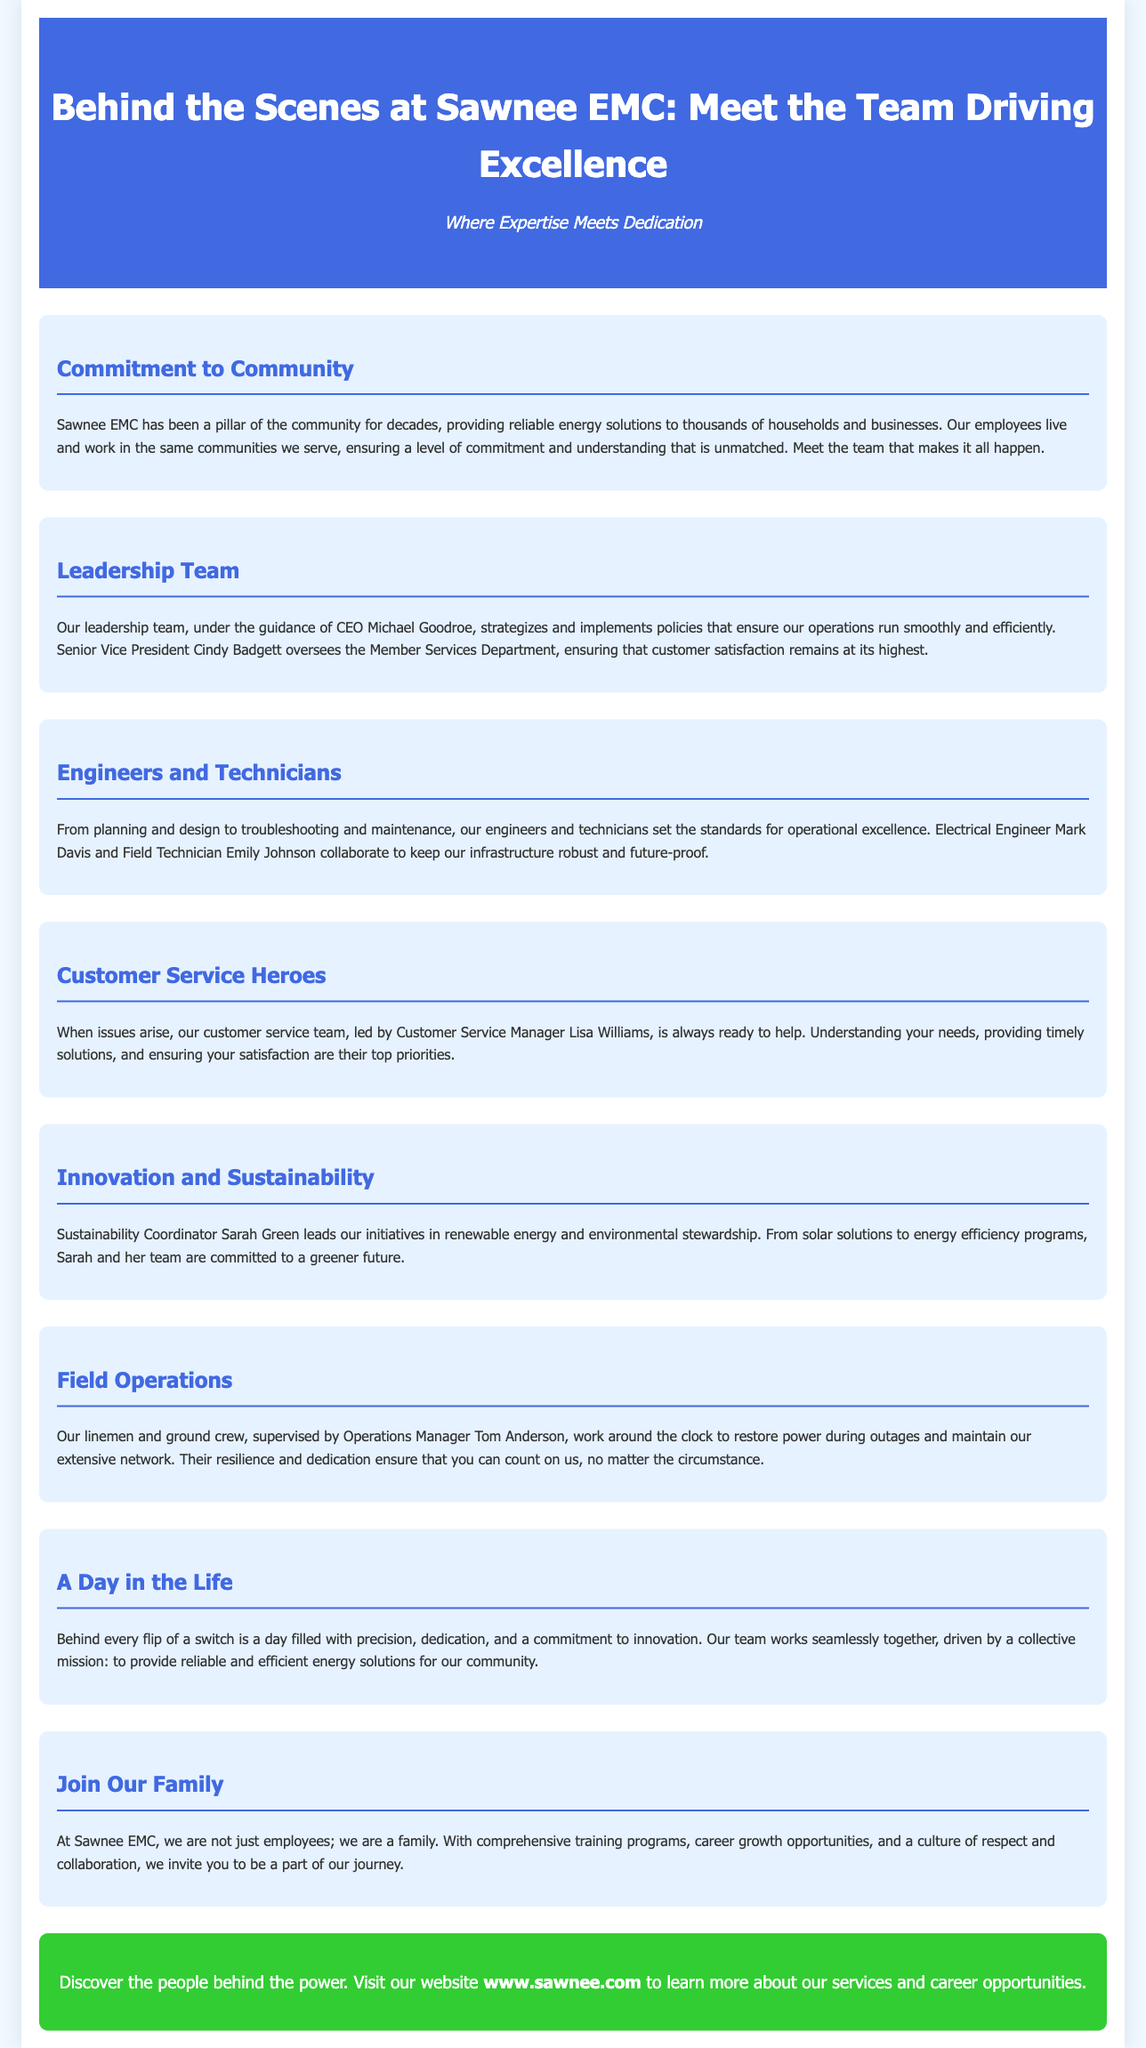What is the title of the advertisement? The title clearly states the focus of the document, which is "Behind the Scenes at Sawnee EMC: Meet the Team Driving Excellence."
Answer: Behind the Scenes at Sawnee EMC: Meet the Team Driving Excellence Who is the CEO of Sawnee EMC? The document mentions the CEO of Sawnee EMC as Michael Goodroe.
Answer: Michael Goodroe What position does Cindy Badgett hold? The document specifies that Cindy Badgett is the Senior Vice President overseeing the Member Services Department.
Answer: Senior Vice President Which renewable energy initiative is led by Sarah Green? The advertisement states that Sarah Green is the Sustainability Coordinator leading initiatives in renewable energy.
Answer: Renewable energy Who are the customer service heroes led by? The document indicates that the Customer Service Manager Lisa Williams leads the customer service team.
Answer: Lisa Williams What is the mission of the Sawnee EMC team? The document summarizes the collective mission of the team as providing reliable and efficient energy solutions for our community.
Answer: Reliable and efficient energy solutions In which department does Tom Anderson work? The advertisement mentions Tom Anderson supervising the field operations.
Answer: Field Operations How does the document describe the employees of Sawnee EMC? The advertisement highlights that employees are described as a family and emphasizes respect and collaboration.
Answer: Family 